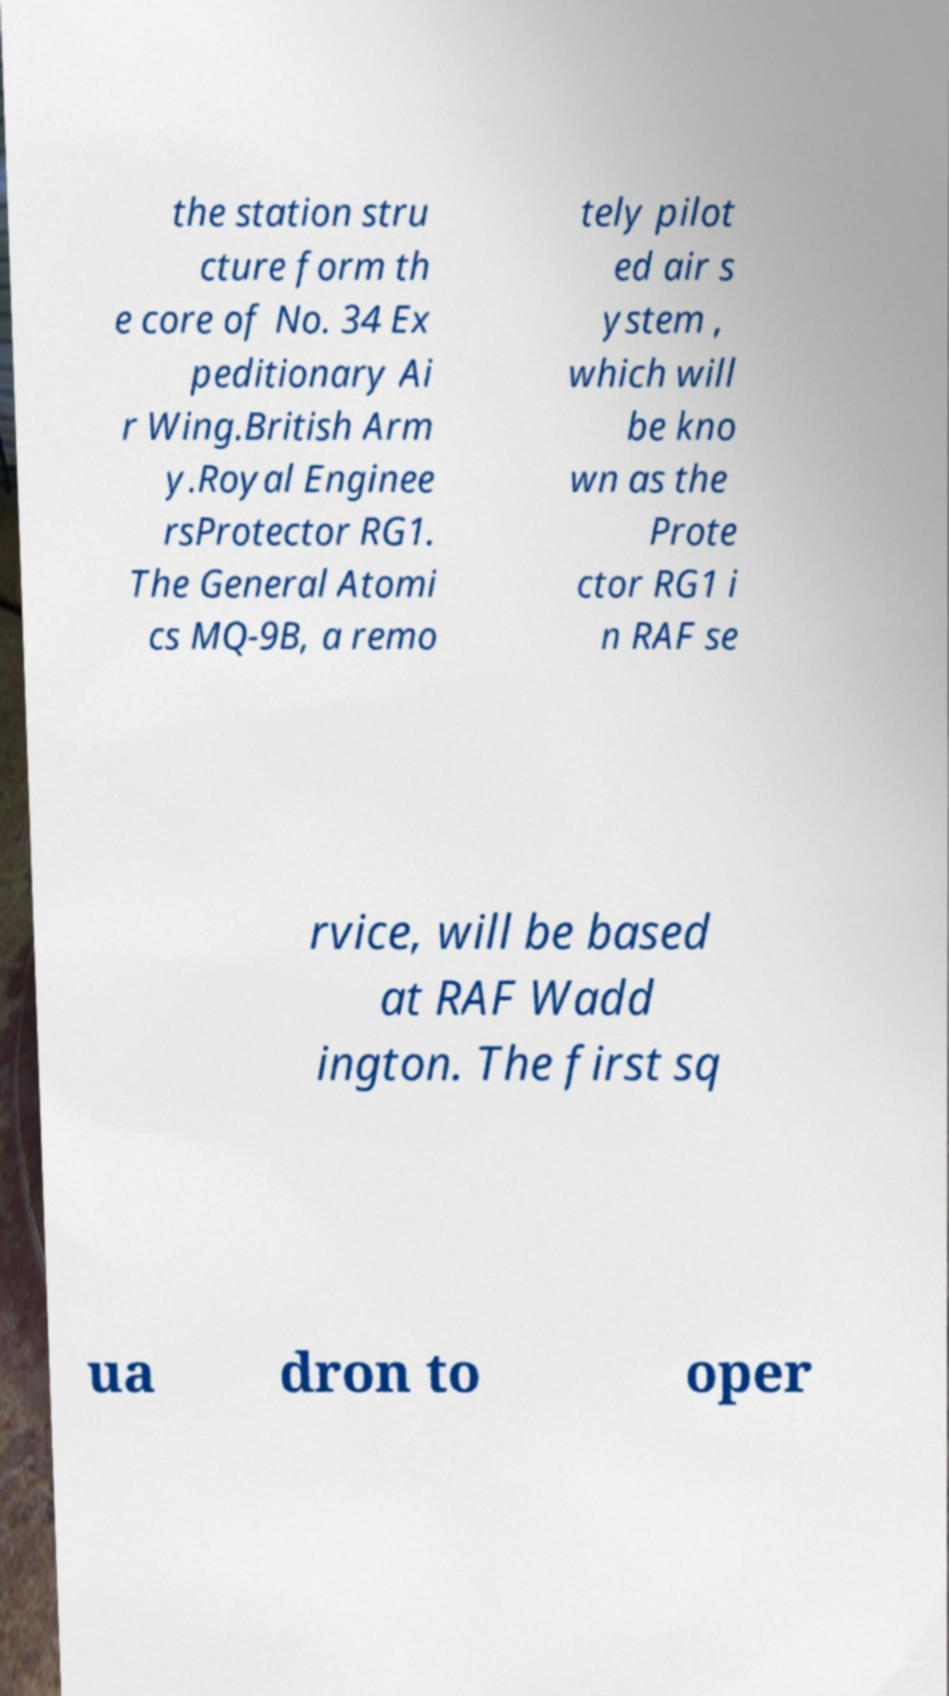I need the written content from this picture converted into text. Can you do that? the station stru cture form th e core of No. 34 Ex peditionary Ai r Wing.British Arm y.Royal Enginee rsProtector RG1. The General Atomi cs MQ-9B, a remo tely pilot ed air s ystem , which will be kno wn as the Prote ctor RG1 i n RAF se rvice, will be based at RAF Wadd ington. The first sq ua dron to oper 